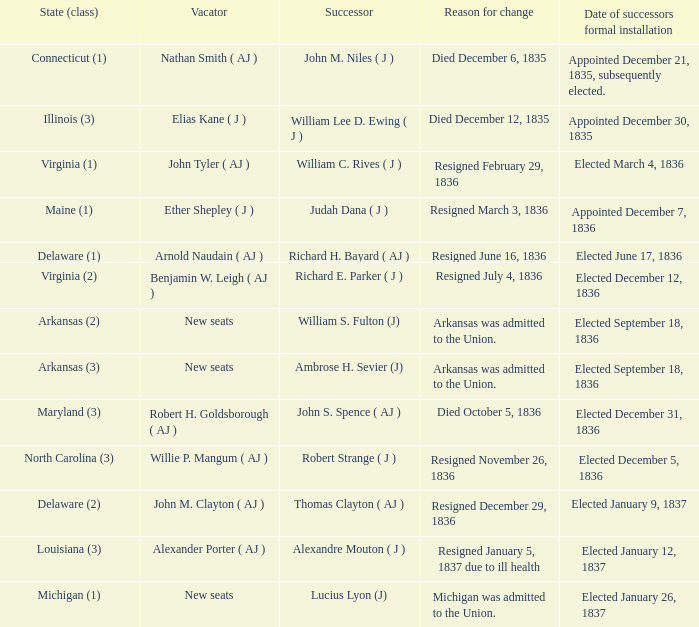Parse the table in full. {'header': ['State (class)', 'Vacator', 'Successor', 'Reason for change', 'Date of successors formal installation'], 'rows': [['Connecticut (1)', 'Nathan Smith ( AJ )', 'John M. Niles ( J )', 'Died December 6, 1835', 'Appointed December 21, 1835, subsequently elected.'], ['Illinois (3)', 'Elias Kane ( J )', 'William Lee D. Ewing ( J )', 'Died December 12, 1835', 'Appointed December 30, 1835'], ['Virginia (1)', 'John Tyler ( AJ )', 'William C. Rives ( J )', 'Resigned February 29, 1836', 'Elected March 4, 1836'], ['Maine (1)', 'Ether Shepley ( J )', 'Judah Dana ( J )', 'Resigned March 3, 1836', 'Appointed December 7, 1836'], ['Delaware (1)', 'Arnold Naudain ( AJ )', 'Richard H. Bayard ( AJ )', 'Resigned June 16, 1836', 'Elected June 17, 1836'], ['Virginia (2)', 'Benjamin W. Leigh ( AJ )', 'Richard E. Parker ( J )', 'Resigned July 4, 1836', 'Elected December 12, 1836'], ['Arkansas (2)', 'New seats', 'William S. Fulton (J)', 'Arkansas was admitted to the Union.', 'Elected September 18, 1836'], ['Arkansas (3)', 'New seats', 'Ambrose H. Sevier (J)', 'Arkansas was admitted to the Union.', 'Elected September 18, 1836'], ['Maryland (3)', 'Robert H. Goldsborough ( AJ )', 'John S. Spence ( AJ )', 'Died October 5, 1836', 'Elected December 31, 1836'], ['North Carolina (3)', 'Willie P. Mangum ( AJ )', 'Robert Strange ( J )', 'Resigned November 26, 1836', 'Elected December 5, 1836'], ['Delaware (2)', 'John M. Clayton ( AJ )', 'Thomas Clayton ( AJ )', 'Resigned December 29, 1836', 'Elected January 9, 1837'], ['Louisiana (3)', 'Alexander Porter ( AJ )', 'Alexandre Mouton ( J )', 'Resigned January 5, 1837 due to ill health', 'Elected January 12, 1837'], ['Michigan (1)', 'New seats', 'Lucius Lyon (J)', 'Michigan was admitted to the Union.', 'Elected January 26, 1837']]} Name the successor for elected january 26, 1837 1.0. 